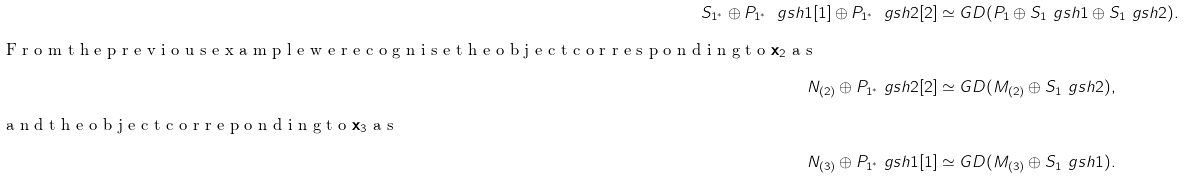Convert formula to latex. <formula><loc_0><loc_0><loc_500><loc_500>S _ { 1 ^ { \ast } } \oplus P _ { 1 ^ { \ast } } \ g s h 1 [ 1 ] \oplus P _ { 1 ^ { \ast } } \ g s h 2 [ 2 ] & \simeq G D ( P _ { 1 } \oplus S _ { 1 } \ g s h 1 \oplus S _ { 1 } \ g s h 2 ) . \\ \intertext { F r o m t h e p r e v i o u s e x a m p l e w e r e c o g n i s e t h e o b j e c t c o r r e s p o n d i n g t o $ \mathbf x _ { 2 } $ a s } N _ { ( 2 ) } \oplus P _ { 1 ^ { \ast } } \ g s h 2 [ 2 ] & \simeq G D ( M _ { ( 2 ) } \oplus S _ { 1 } \ g s h 2 ) , \intertext { a n d t h e o b j e c t c o r r e p o n d i n g t o $ \mathbf x _ { 3 } $ a s } N _ { ( 3 ) } \oplus P _ { 1 ^ { \ast } } \ g s h 1 [ 1 ] & \simeq G D ( M _ { ( 3 ) } \oplus S _ { 1 } \ g s h 1 ) .</formula> 